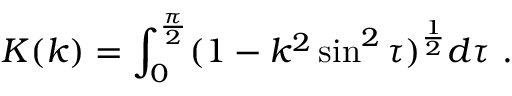<formula> <loc_0><loc_0><loc_500><loc_500>K ( k ) = \int _ { 0 } ^ { \frac { \pi } { 2 } } ( 1 - k ^ { 2 } \sin ^ { 2 } \tau ) ^ { \frac { 1 } { 2 } } d \tau \ .</formula> 